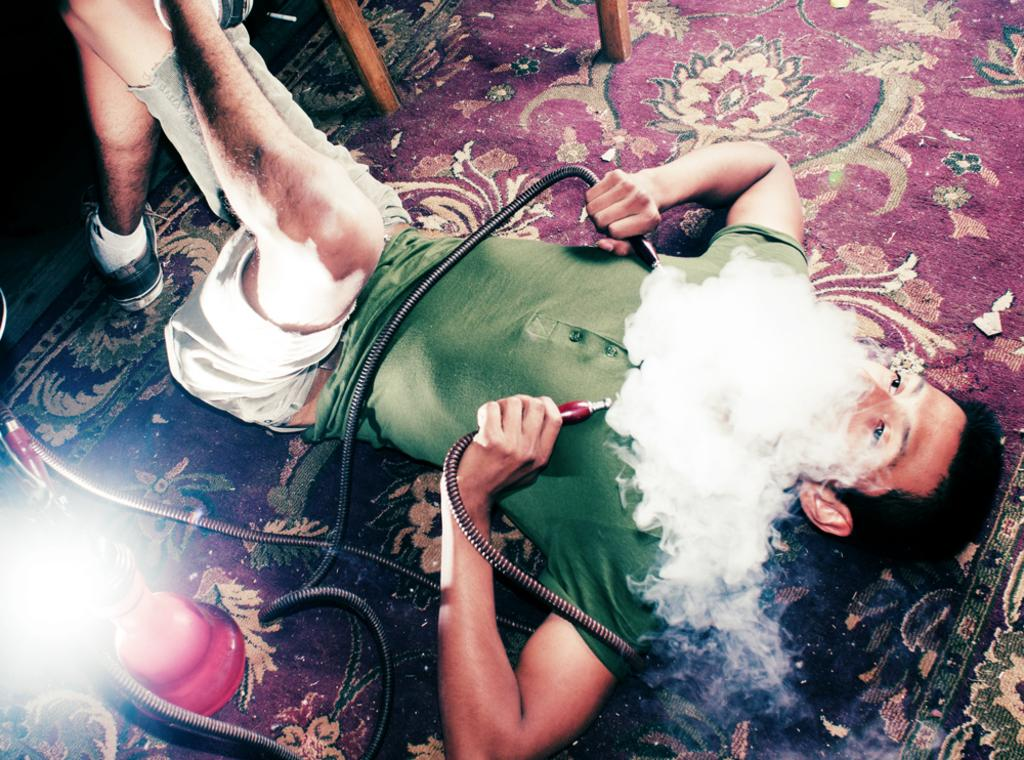Who is present in the image? There is a boy in the image. What is the boy wearing? The boy is wearing a green t-shirt. What is the boy doing in the image? The boy is lying on a red carpet and smoking hookah. What type of hookah is visible in the image? There is a red hookah in the image. What is connected to the hookah? There is a pipe associated with the hookah. What can be seen coming from the hookah? There is smoke visible in the image. What type of bears can be seen playing in the waves in the image? There are no bears or waves present in the image; it features a boy lying on a red carpet and smoking hookah. 